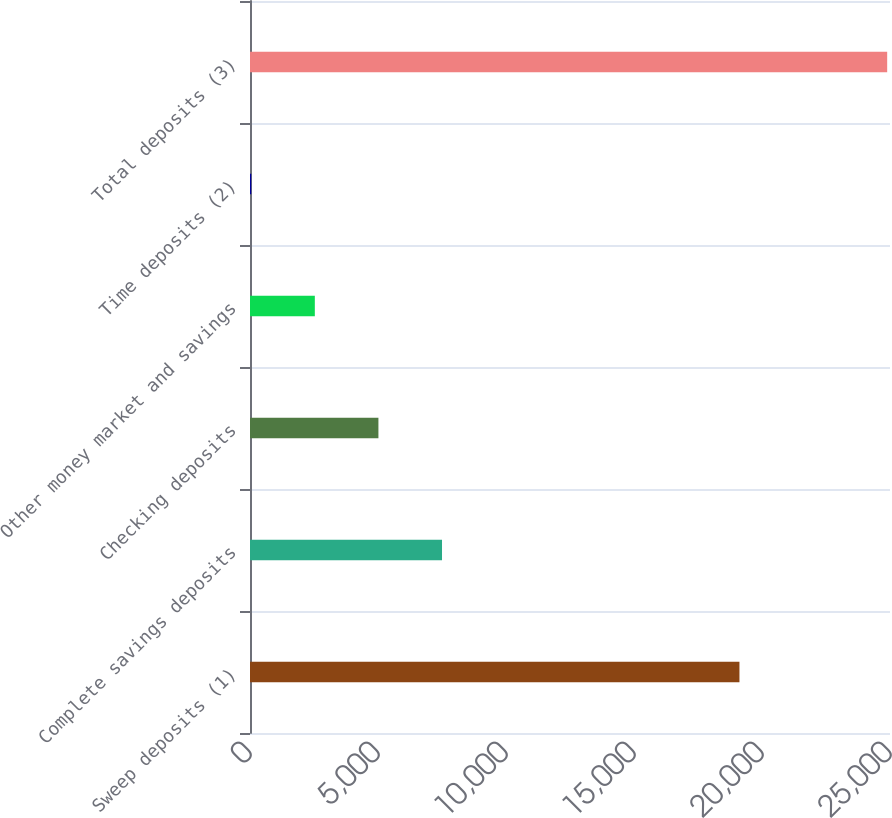Convert chart. <chart><loc_0><loc_0><loc_500><loc_500><bar_chart><fcel>Sweep deposits (1)<fcel>Complete savings deposits<fcel>Checking deposits<fcel>Other money market and savings<fcel>Time deposits (2)<fcel>Total deposits (3)<nl><fcel>19119<fcel>7500.6<fcel>5016.4<fcel>2532.2<fcel>48<fcel>24890<nl></chart> 